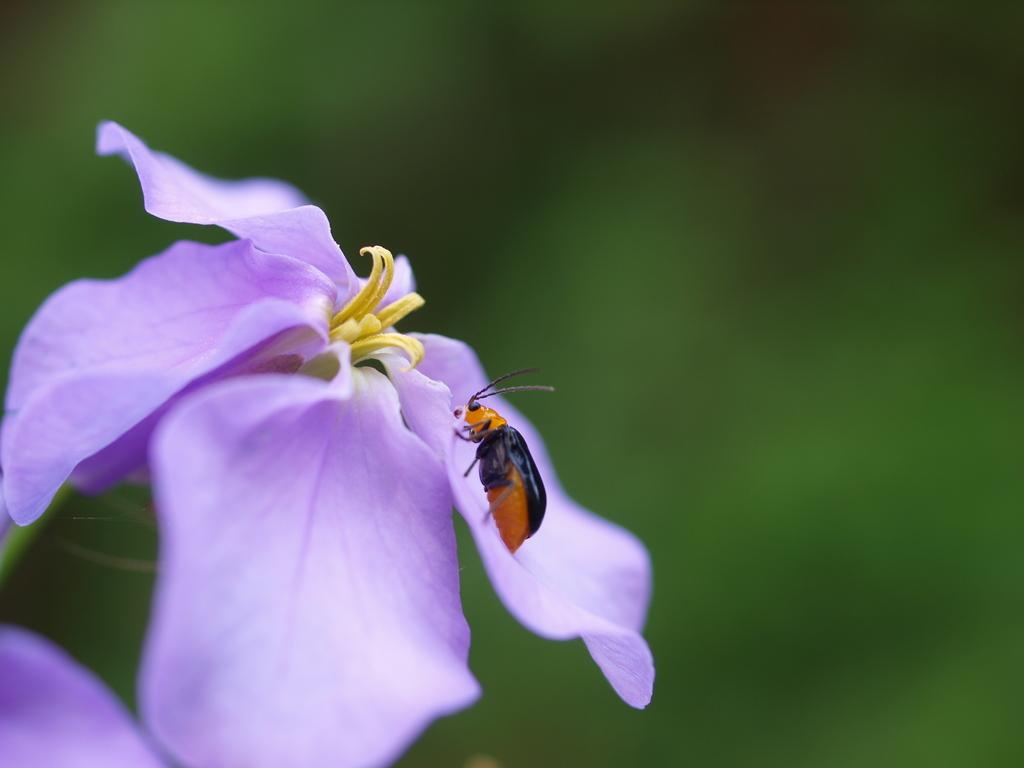What type of creature is in the image? There is an insect in the image. What colors can be seen on the insect? The insect is in black and orange color. What other object is in the image? There is a flower in the image. What colors can be seen on the flower? The flower is in yellow and purple color. Where is the insect located in relation to the flower? The insect is on the flower. Can you see a boy playing with a pan on the coast in the image? No, there is no boy, pan, or coast present in the image. The image features an insect on a flower with specific colors. 